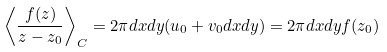<formula> <loc_0><loc_0><loc_500><loc_500>\left \langle \frac { f ( z ) } { z - z _ { 0 } } \right \rangle _ { C } = 2 \pi d x d y ( u _ { 0 } + v _ { 0 } d x d y ) = 2 \pi d x d y f ( z _ { 0 } )</formula> 